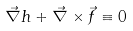<formula> <loc_0><loc_0><loc_500><loc_500>\vec { \nabla } h + \vec { \nabla } \times \vec { f } \equiv 0</formula> 